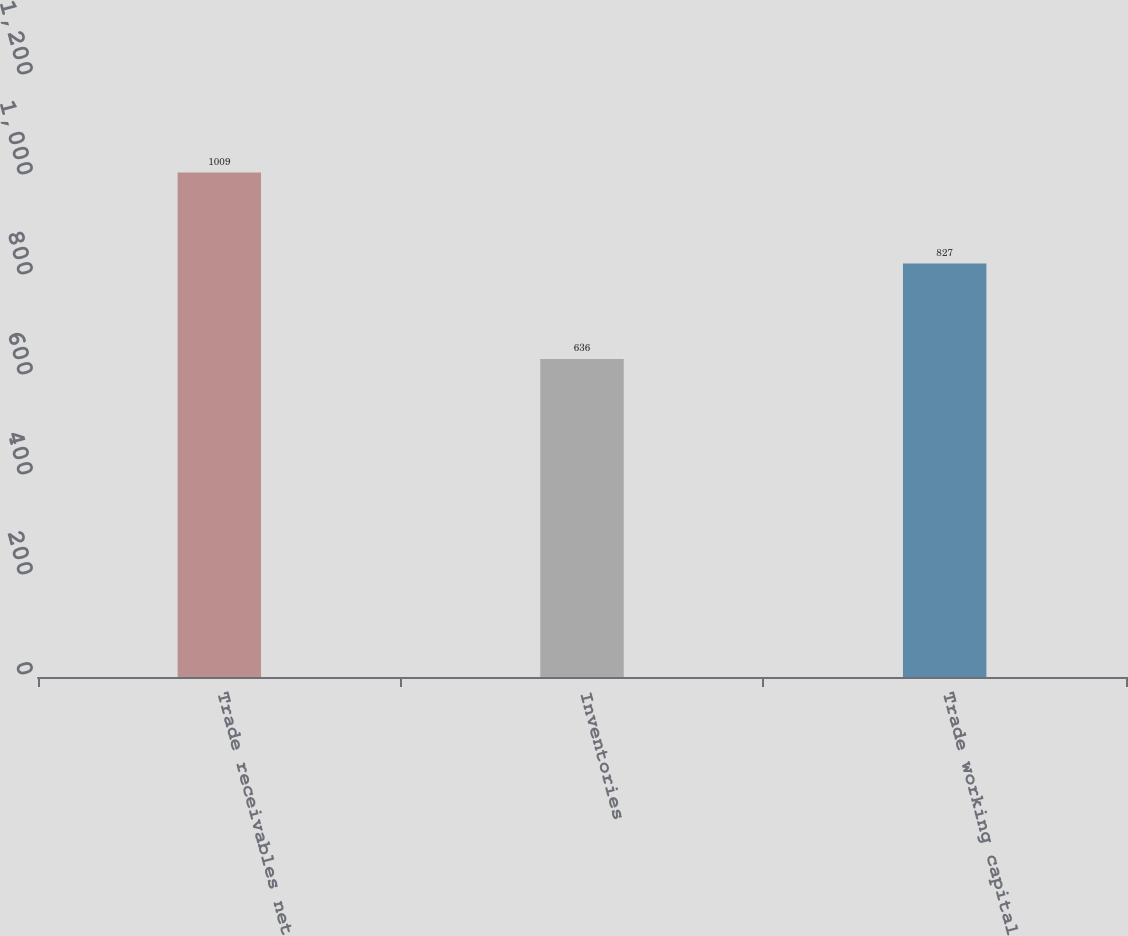Convert chart to OTSL. <chart><loc_0><loc_0><loc_500><loc_500><bar_chart><fcel>Trade receivables net<fcel>Inventories<fcel>Trade working capital<nl><fcel>1009<fcel>636<fcel>827<nl></chart> 